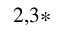<formula> <loc_0><loc_0><loc_500><loc_500>^ { 2 , 3 * }</formula> 